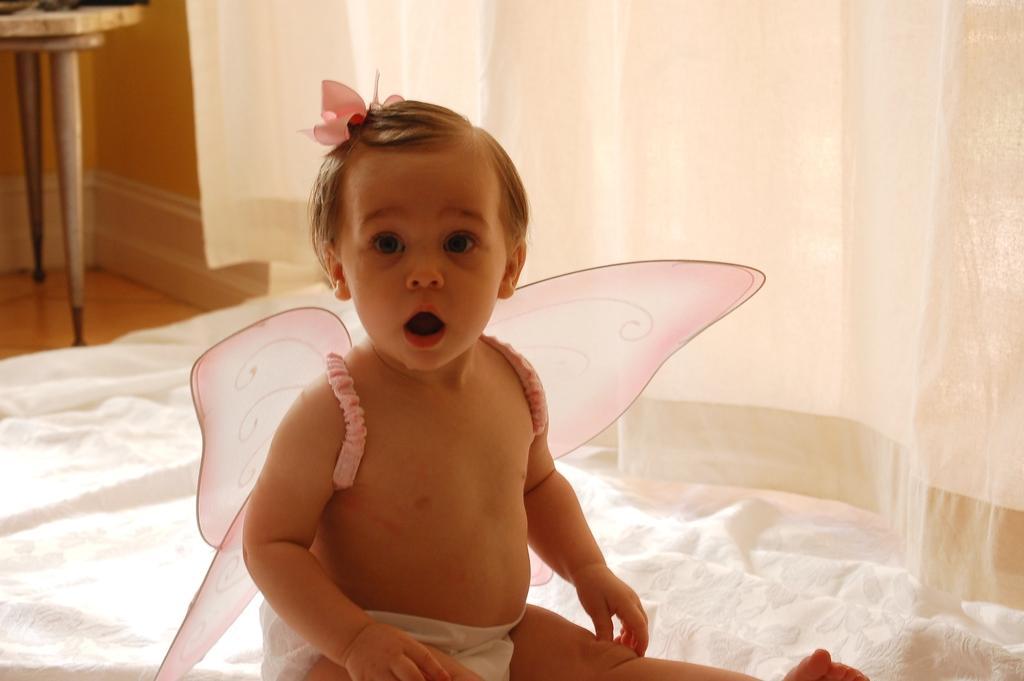Describe this image in one or two sentences. In this image, we can see a baby is wearing costume and sitting. Here we can see cloth and curtains. Left side top of the image, there is a wall, floor and table. 